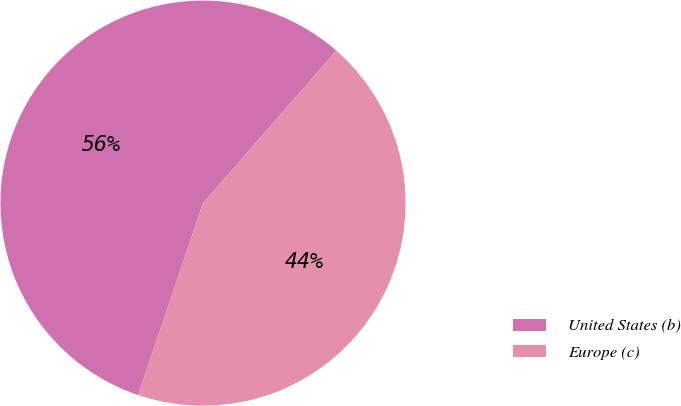<chart> <loc_0><loc_0><loc_500><loc_500><pie_chart><fcel>United States (b)<fcel>Europe (c)<nl><fcel>56.24%<fcel>43.76%<nl></chart> 